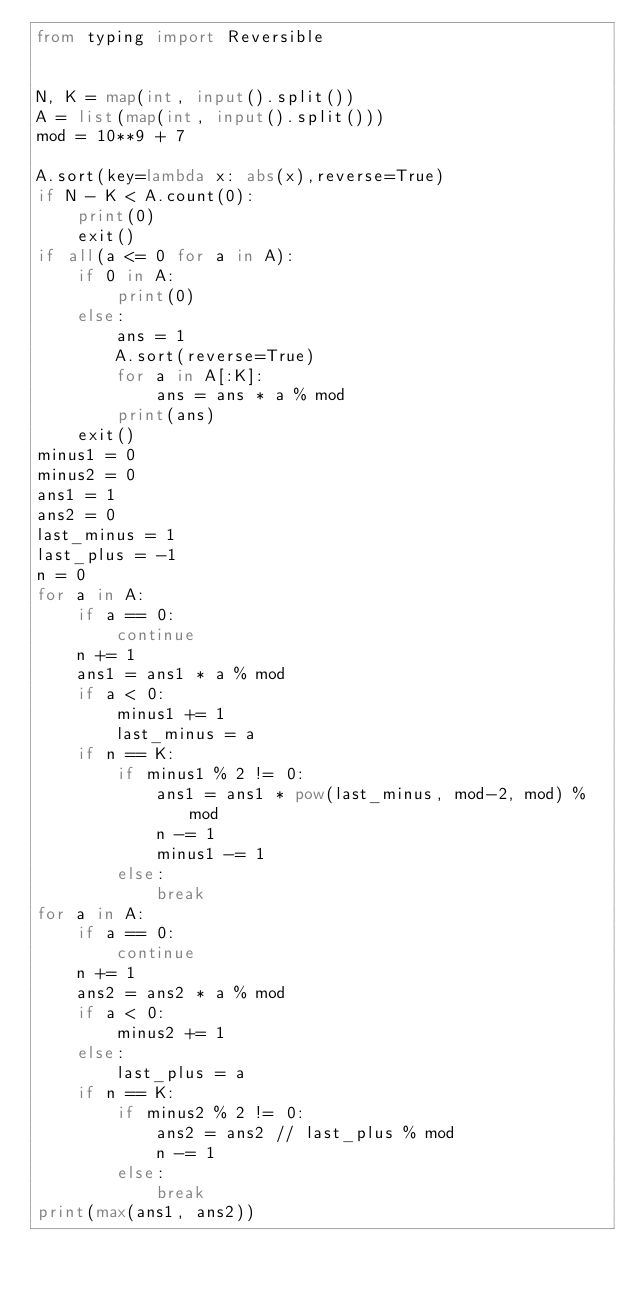Convert code to text. <code><loc_0><loc_0><loc_500><loc_500><_Python_>from typing import Reversible


N, K = map(int, input().split())
A = list(map(int, input().split()))
mod = 10**9 + 7

A.sort(key=lambda x: abs(x),reverse=True)
if N - K < A.count(0):
    print(0)
    exit()
if all(a <= 0 for a in A):
    if 0 in A:
        print(0)
    else:
        ans = 1
        A.sort(reverse=True)
        for a in A[:K]:
            ans = ans * a % mod
        print(ans)
    exit()
minus1 = 0
minus2 = 0
ans1 = 1
ans2 = 0
last_minus = 1
last_plus = -1
n = 0
for a in A:
    if a == 0:
        continue
    n += 1
    ans1 = ans1 * a % mod
    if a < 0:
        minus1 += 1
        last_minus = a
    if n == K:
        if minus1 % 2 != 0:
            ans1 = ans1 * pow(last_minus, mod-2, mod) % mod
            n -= 1
            minus1 -= 1
        else:
            break
for a in A:
    if a == 0:
        continue
    n += 1
    ans2 = ans2 * a % mod
    if a < 0:
        minus2 += 1
    else:
        last_plus = a
    if n == K:
        if minus2 % 2 != 0:
            ans2 = ans2 // last_plus % mod
            n -= 1
        else:
            break
print(max(ans1, ans2))</code> 